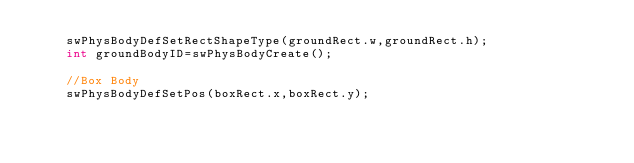Convert code to text. <code><loc_0><loc_0><loc_500><loc_500><_C++_>	swPhysBodyDefSetRectShapeType(groundRect.w,groundRect.h);
	int groundBodyID=swPhysBodyCreate();

	//Box Body
	swPhysBodyDefSetPos(boxRect.x,boxRect.y);</code> 